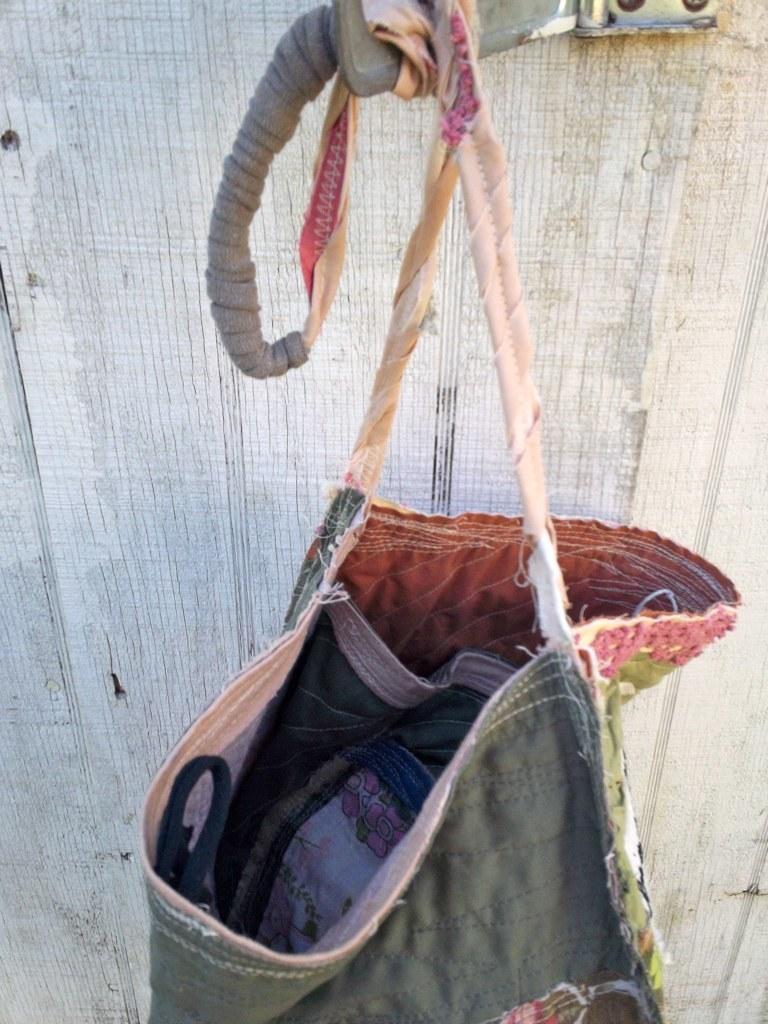Can you describe this image briefly? In this image, There is a bag of gray color which is hanging on the clip of white color, In the background there is a wall of white color. 